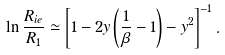<formula> <loc_0><loc_0><loc_500><loc_500>\ln \frac { R _ { i e } } { R _ { 1 } } \simeq \left [ 1 - 2 y \left ( \frac { 1 } { \beta } - 1 \right ) - y ^ { 2 } \right ] ^ { - 1 } .</formula> 